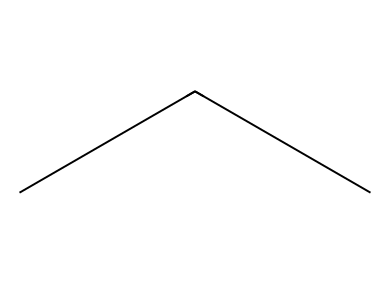What is the number of carbon atoms in propane? The SMILES representation "CCC" indicates three consecutive carbon atoms. Smiles notation shows atoms in a linear arrangement, and each 'C' corresponds to one carbon atom.
Answer: 3 How many hydrogen atoms are bonded to propane? Each carbon in propane forms four bonds. The three carbon atoms are arranged in a straight chain, resulting in maximum hydrogen atoms being bonded to each carbon. Following the alkane formula CnH(2n+2), where n = 3, we find that propane has 8 hydrogen atoms.
Answer: 8 What is the functional group in propane? Propane is a hydrocarbon and does not contain functional groups such as alcohols or carboxylic acids. It consists only of carbon and hydrogen atoms, making it an alkane.
Answer: none How does the molecular structure of propane affect its refrigerant properties? The linear structure of propane allows for low boiling points and good thermodynamic properties when used as a refrigerant. These properties result in efficient heat transfer and phase changes necessary for refrigeration.
Answer: efficient heat transfer Is propane a saturated or unsaturated hydrocarbon? Propane contains only single bonds between carbon atoms, classifying it as a saturated hydrocarbon since it has the maximum number of hydrogen atoms per carbon atoms possible.
Answer: saturated What is the significance of using propane as a refrigerant? Propane is environmentally friendly due to its low global warming potential (GWP) and ozone depletion potential (ODP), making it a preferred refrigerant in small appliances over harmful alternatives.
Answer: environmentally friendly 